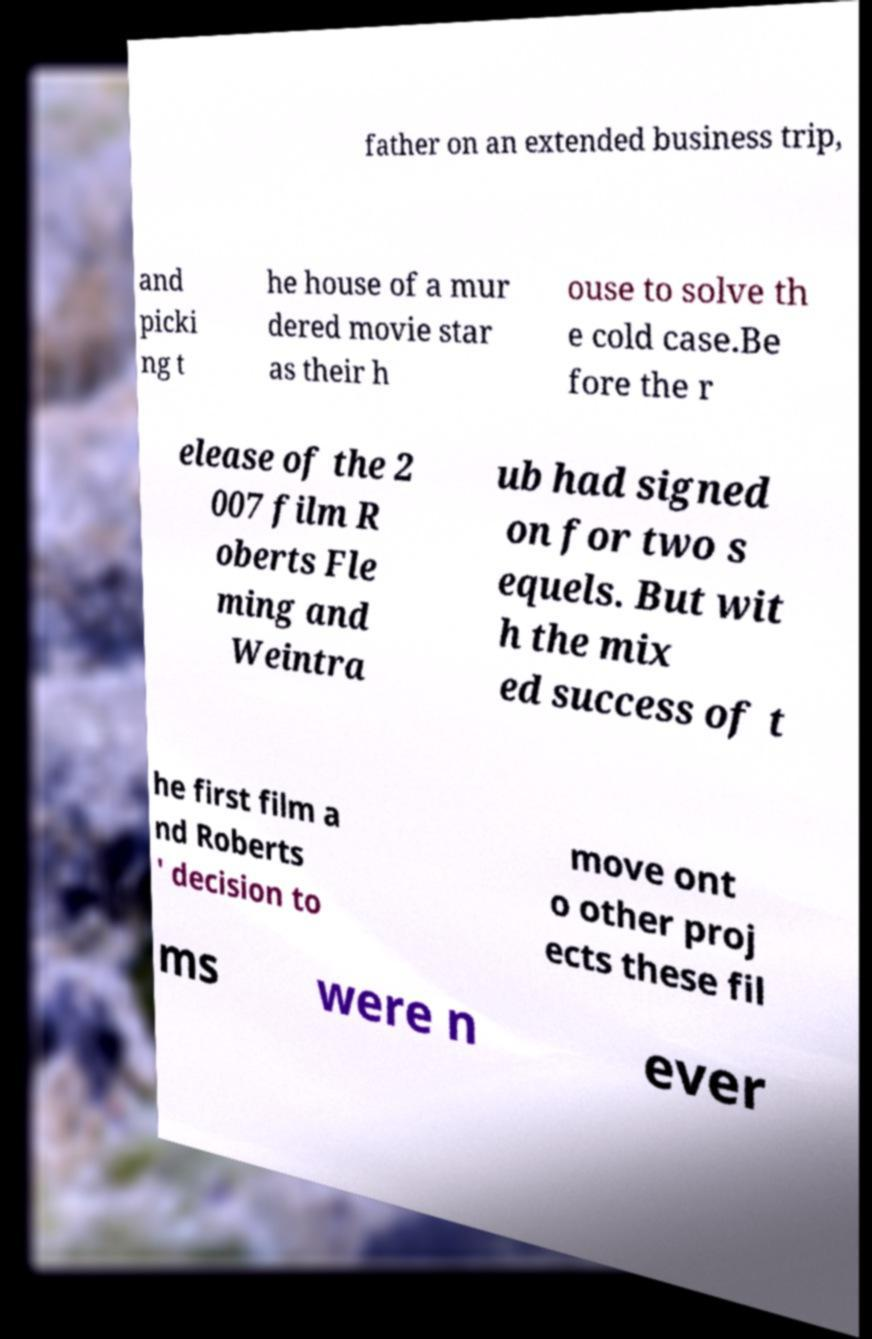Can you accurately transcribe the text from the provided image for me? father on an extended business trip, and picki ng t he house of a mur dered movie star as their h ouse to solve th e cold case.Be fore the r elease of the 2 007 film R oberts Fle ming and Weintra ub had signed on for two s equels. But wit h the mix ed success of t he first film a nd Roberts ' decision to move ont o other proj ects these fil ms were n ever 